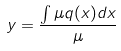<formula> <loc_0><loc_0><loc_500><loc_500>y = \frac { \int \mu q ( x ) d x } { \mu }</formula> 